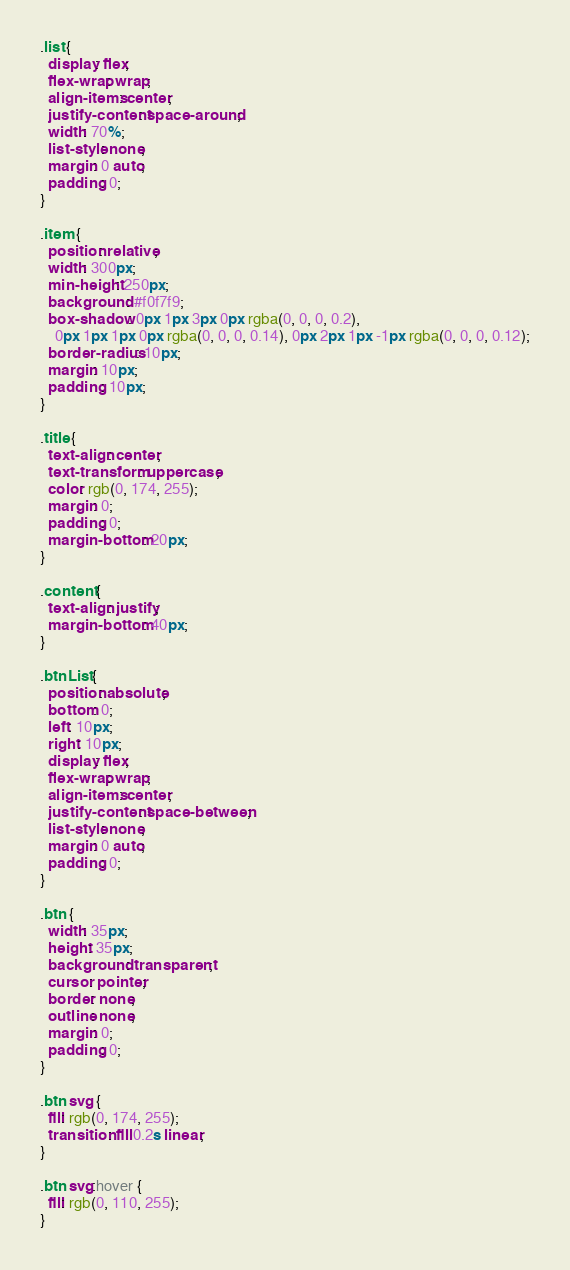Convert code to text. <code><loc_0><loc_0><loc_500><loc_500><_CSS_>.list {
  display: flex;
  flex-wrap: wrap;
  align-items: center;
  justify-content: space-around;
  width: 70%;
  list-style: none;
  margin: 0 auto;
  padding: 0;
}

.item {
  position: relative;
  width: 300px;
  min-height: 250px;
  background: #f0f7f9;
  box-shadow: 0px 1px 3px 0px rgba(0, 0, 0, 0.2),
    0px 1px 1px 0px rgba(0, 0, 0, 0.14), 0px 2px 1px -1px rgba(0, 0, 0, 0.12);
  border-radius: 10px;
  margin: 10px;
  padding: 10px;
}

.title {
  text-align: center;
  text-transform: uppercase;
  color: rgb(0, 174, 255);
  margin: 0;
  padding: 0;
  margin-bottom: 20px;
}

.content {
  text-align: justify;
  margin-bottom: 40px;
}

.btnList {
  position: absolute;
  bottom: 0;
  left: 10px;
  right: 10px;
  display: flex;
  flex-wrap: wrap;
  align-items: center;
  justify-content: space-between;
  list-style: none;
  margin: 0 auto;
  padding: 0;
}

.btn {
  width: 35px;
  height: 35px;
  background: transparent;
  cursor: pointer;
  border: none;
  outline: none;
  margin: 0;
  padding: 0;
}

.btn svg {
  fill: rgb(0, 174, 255);
  transition: fill 0.2s linear;
}

.btn svg:hover {
  fill: rgb(0, 110, 255);
}
</code> 